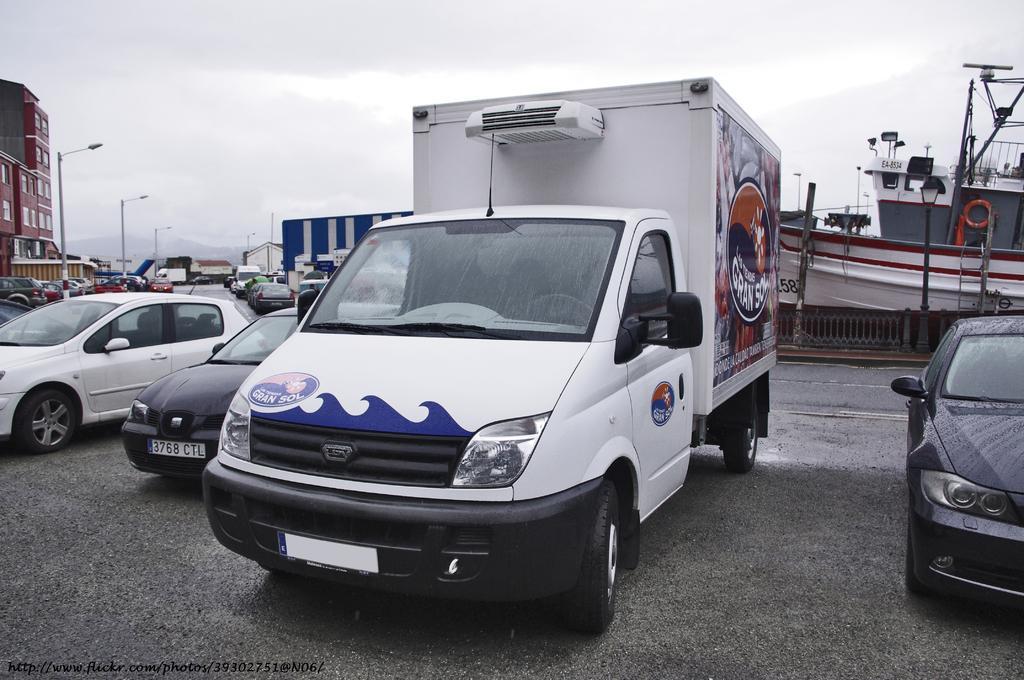Describe this image in one or two sentences. In this image we can see many cars parked on the road. In the background there is a ship, buildings, light poles, sky and clouds. 